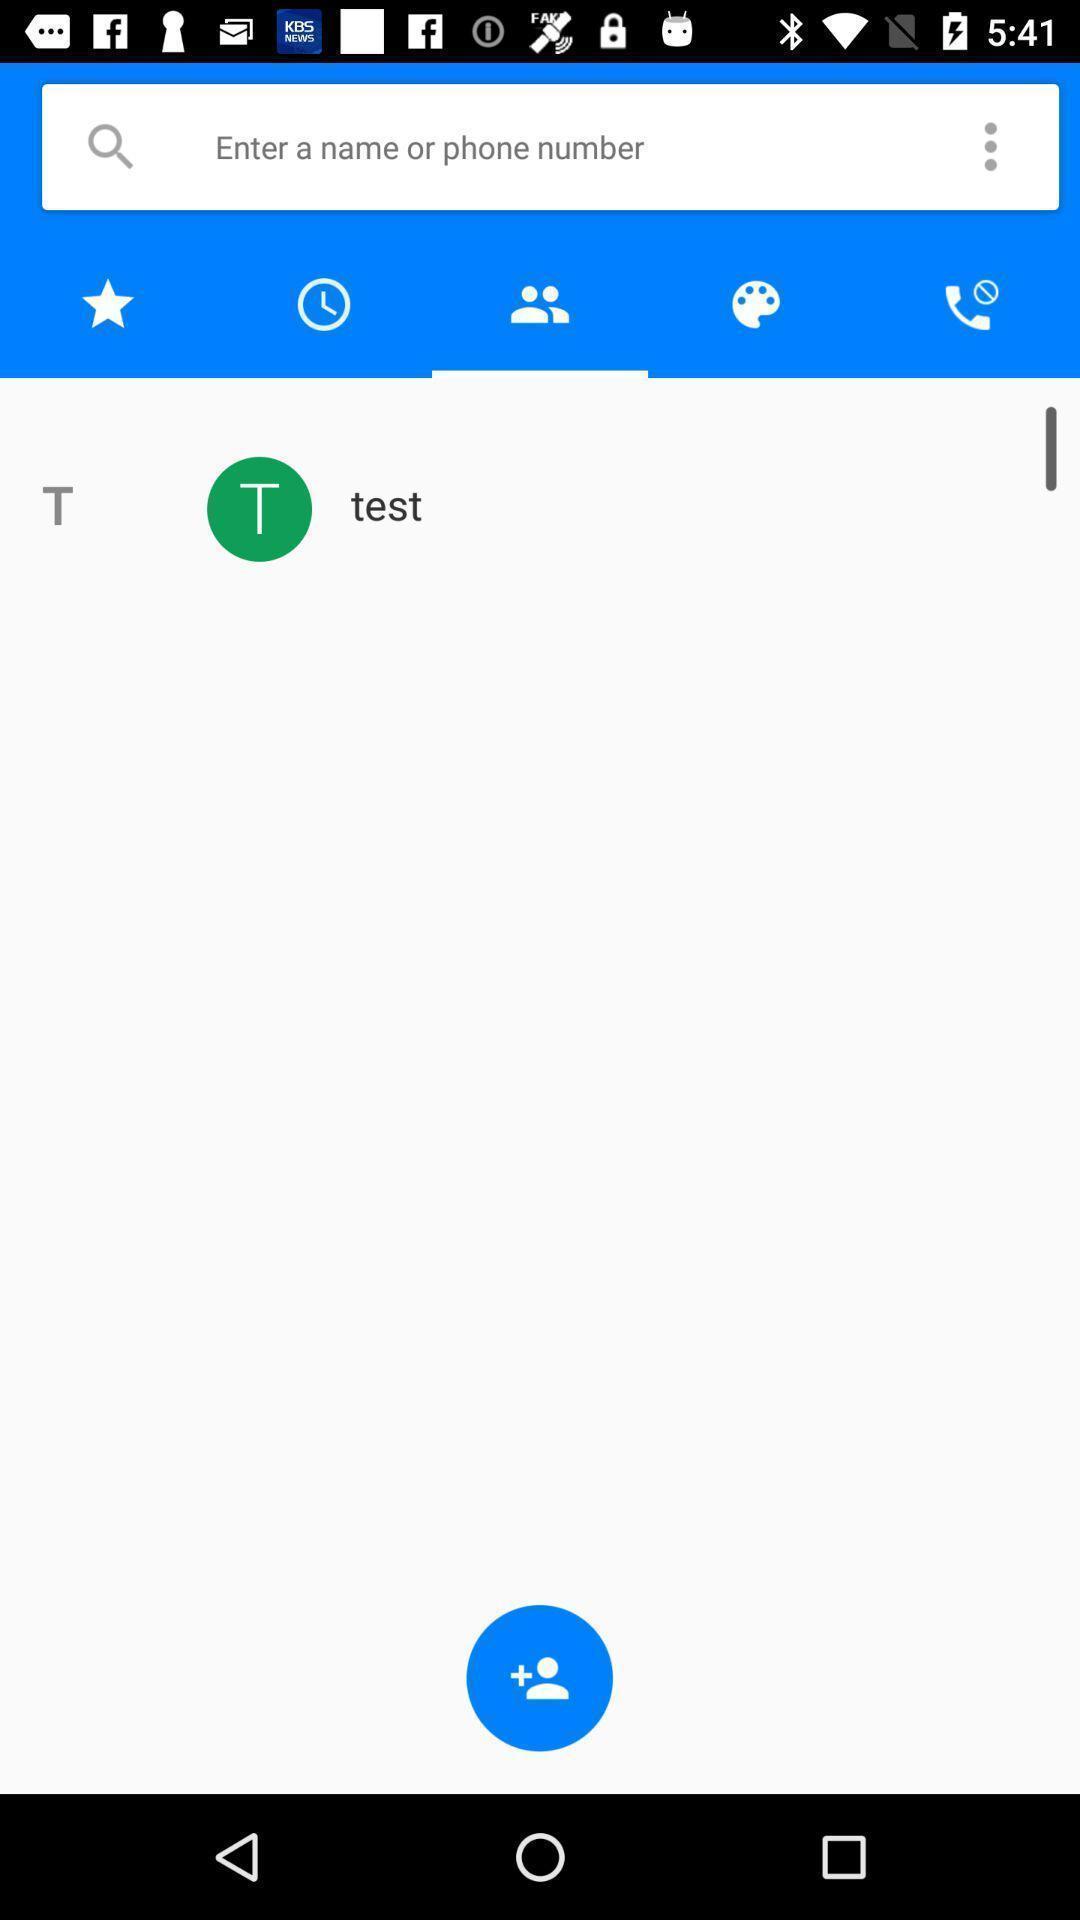What can you discern from this picture? Search bar to search for a contact number. 